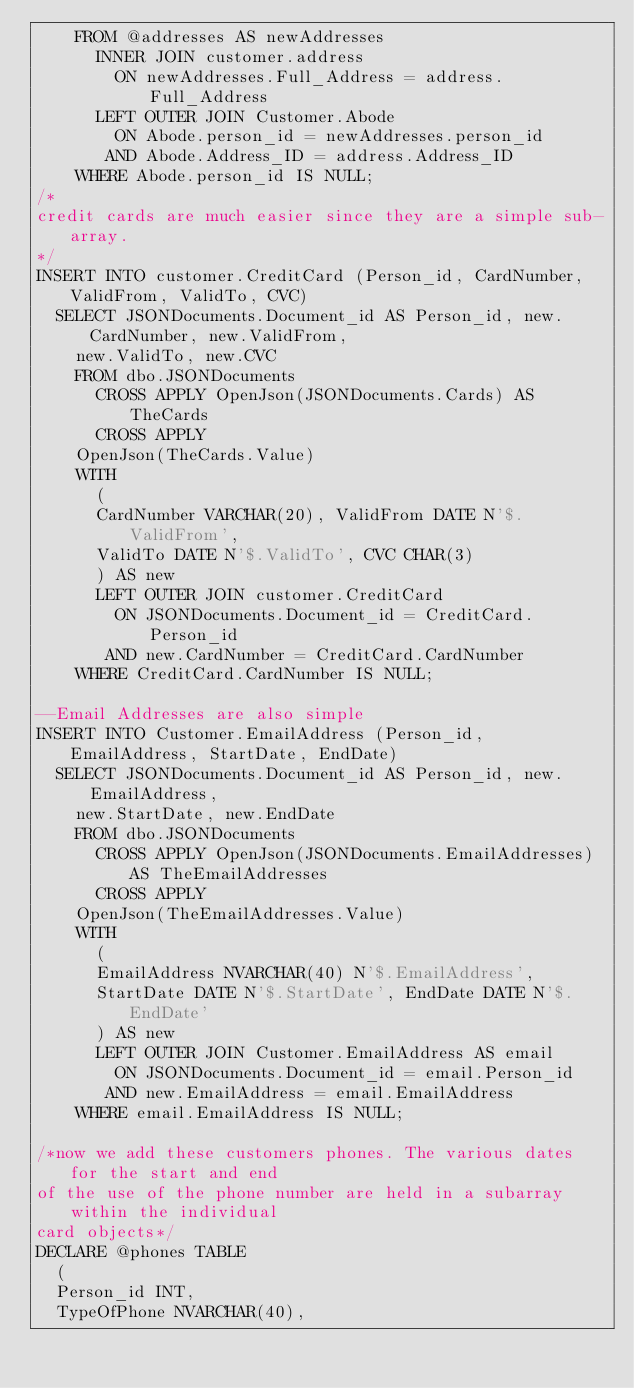Convert code to text. <code><loc_0><loc_0><loc_500><loc_500><_SQL_>    FROM @addresses AS newAddresses
      INNER JOIN customer.address
        ON newAddresses.Full_Address = address.Full_Address
      LEFT OUTER JOIN Customer.Abode
        ON Abode.person_id = newAddresses.person_id
       AND Abode.Address_ID = address.Address_ID
    WHERE Abode.person_id IS NULL;
/*
credit cards are much easier since they are a simple sub-array.
*/
INSERT INTO customer.CreditCard (Person_id, CardNumber, ValidFrom, ValidTo, CVC)
  SELECT JSONDocuments.Document_id AS Person_id, new.CardNumber, new.ValidFrom,
    new.ValidTo, new.CVC
    FROM dbo.JSONDocuments
      CROSS APPLY OpenJson(JSONDocuments.Cards) AS TheCards
      CROSS APPLY
    OpenJson(TheCards.Value)
    WITH
      (
      CardNumber VARCHAR(20), ValidFrom DATE N'$.ValidFrom',
      ValidTo DATE N'$.ValidTo', CVC CHAR(3)
      ) AS new
      LEFT OUTER JOIN customer.CreditCard
        ON JSONDocuments.Document_id = CreditCard.Person_id
       AND new.CardNumber = CreditCard.CardNumber
    WHERE CreditCard.CardNumber IS NULL;

--Email Addresses are also simple 
INSERT INTO Customer.EmailAddress (Person_id, EmailAddress, StartDate, EndDate)
  SELECT JSONDocuments.Document_id AS Person_id, new.EmailAddress,
    new.StartDate, new.EndDate
    FROM dbo.JSONDocuments
      CROSS APPLY OpenJson(JSONDocuments.EmailAddresses) AS TheEmailAddresses
      CROSS APPLY
    OpenJson(TheEmailAddresses.Value)
    WITH
      (
      EmailAddress NVARCHAR(40) N'$.EmailAddress',
      StartDate DATE N'$.StartDate', EndDate DATE N'$.EndDate'
      ) AS new
      LEFT OUTER JOIN Customer.EmailAddress AS email
        ON JSONDocuments.Document_id = email.Person_id
       AND new.EmailAddress = email.EmailAddress
    WHERE email.EmailAddress IS NULL;

/*now we add these customers phones. The various dates for the start and end
of the use of the phone number are held in a subarray within the individual
card objects*/
DECLARE @phones TABLE
  (
  Person_id INT,
  TypeOfPhone NVARCHAR(40),</code> 